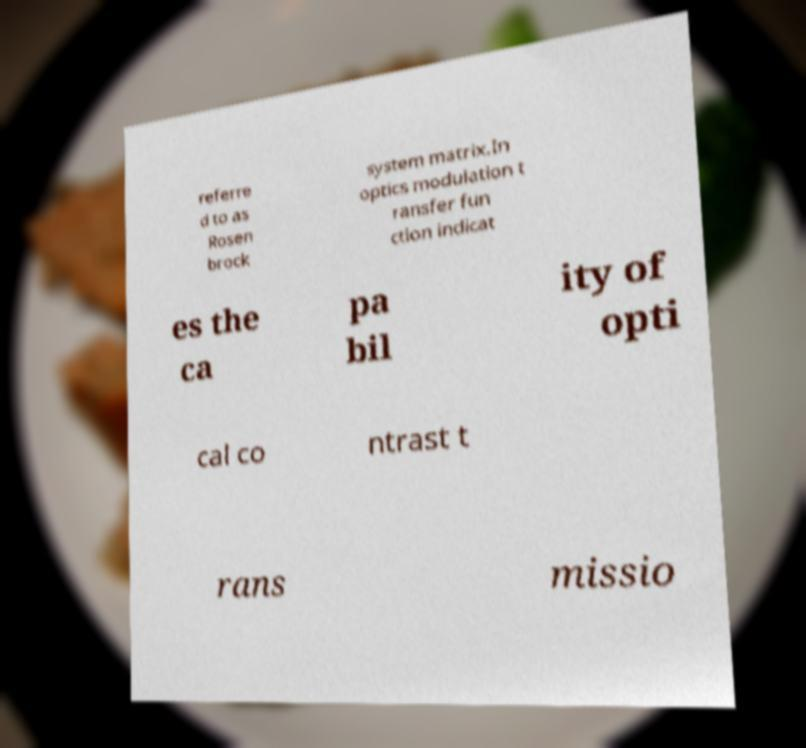I need the written content from this picture converted into text. Can you do that? referre d to as Rosen brock system matrix.In optics modulation t ransfer fun ction indicat es the ca pa bil ity of opti cal co ntrast t rans missio 